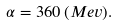<formula> <loc_0><loc_0><loc_500><loc_500>\alpha = 3 6 0 \, ( M e v ) .</formula> 